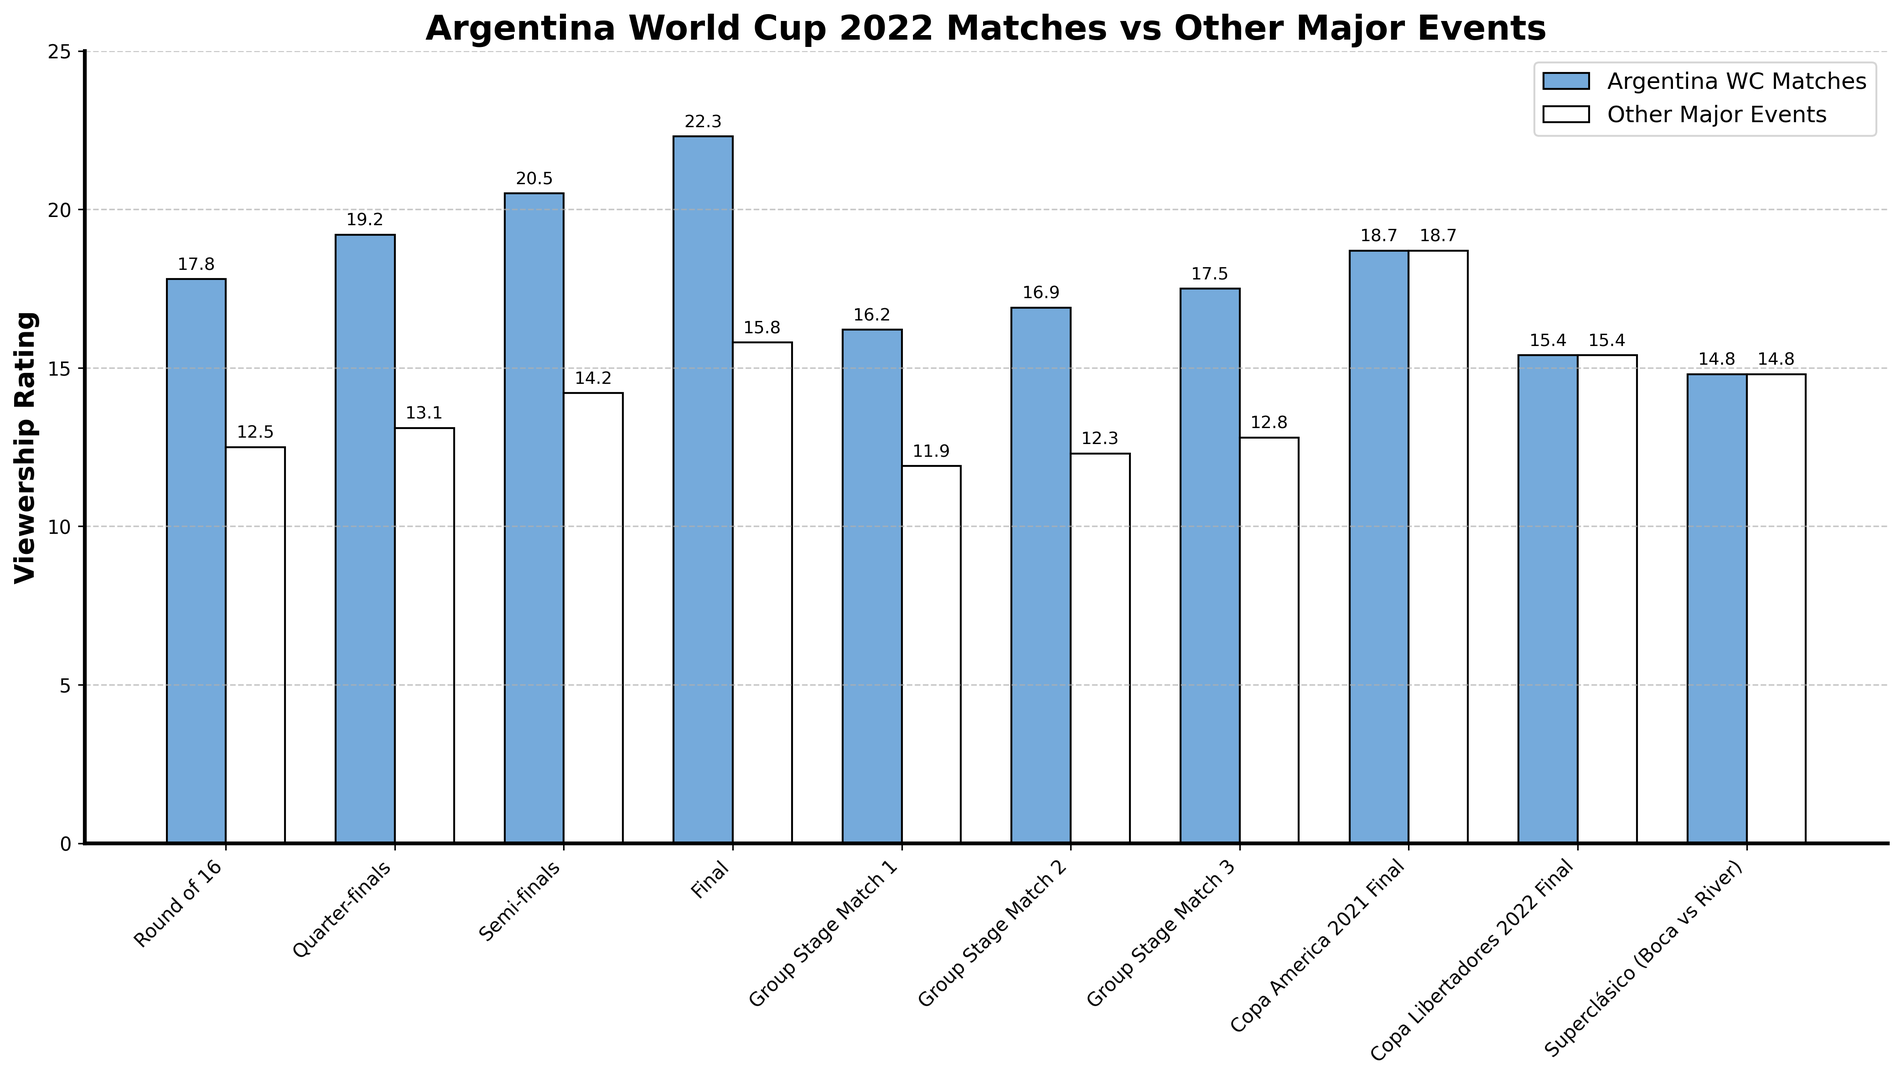What is the difference in viewership rating between Argentina's Final WC Match and the Round of 16 match? The viewership rating for Argentina's Final WC Match is 22.3, while for the Round of 16 match it is 17.8. The difference is calculated as 22.3 - 17.8 = 4.5.
Answer: 4.5 Which event had the highest viewership rating: Argentina WC Matches or Other Major Events? The bar for the Final match in Argentina WC Matches reaches the highest point at 22.3, and this is higher than any bar in Other Major Events.
Answer: Argentina WC Matches, Final Was the viewership rating for Argentina's Quarter-finals WC match higher, lower, or equal to that of the Copa America 2021 Final? The viewership rating for Argentina's Quarter-finals WC match is 19.2, while it is 18.7 for the Copa America 2021 Final. 19.2 is higher than 18.7.
Answer: Higher Considering the three Group Stage matches for Argentina WC Matches, what is their average viewership rating? The viewership ratings for the three Group Stage matches are 16.2, 16.9, and 17.5. Their average is calculated as (16.2 + 16.9 + 17.5) / 3 = 50.6 / 3 = 16.87.
Answer: 16.87 By how much does the viewership rating for the Semi-finals in Argentina WC Matches exceed the Superclásico event? The viewership rating for the Semi-finals in Argentina WC Matches is 20.5, and for the Superclásico, it is 14.8. The difference is 20.5 - 14.8 = 5.7.
Answer: 5.7 How does the viewership rating for Argentina's Group Stage Match 2 compare to the Copa Libertadores 2022 Final? The viewership rating for Argentina's Group Stage Match 2 is 16.9, while for the Copa Libertadores 2022 Final it is 15.4. Therefore, 16.9 is greater than 15.4.
Answer: Greater Which Argentina WC Match had the lowest viewership rating, and what was it? The lowest viewership rating among Argentina's WC Matches is for Group Stage Match 1, which is at 16.2.
Answer: Group Stage Match 1, 16.2 